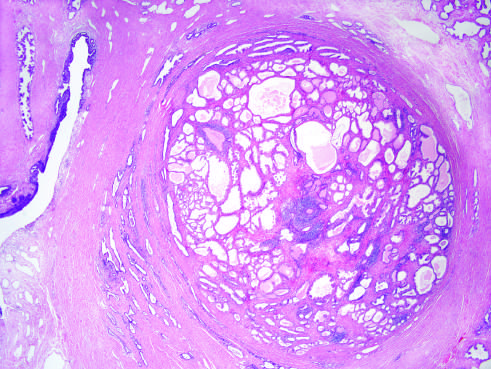s the nodularity caused predominantly by stromal, rather than glandular, proliferation in other cases of nodular hyperplasia?
Answer the question using a single word or phrase. Yes 